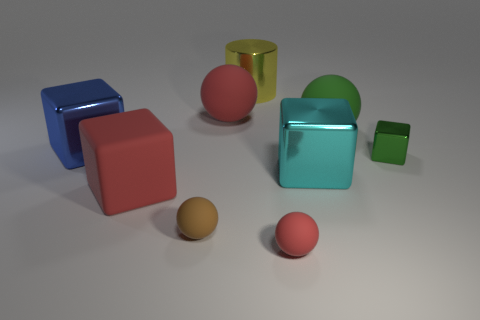What shape is the big shiny thing that is in front of the big red rubber ball and to the right of the red block?
Your answer should be very brief. Cube. Are there any tiny brown spheres?
Your answer should be very brief. Yes. There is a red thing that is the same shape as the cyan metal thing; what is it made of?
Offer a terse response. Rubber. There is a large rubber thing that is on the right side of the red sphere in front of the large cube that is right of the yellow metal cylinder; what is its shape?
Your answer should be very brief. Sphere. There is a big sphere that is the same color as the tiny metal object; what is it made of?
Keep it short and to the point. Rubber. What number of other big green matte objects have the same shape as the large green object?
Keep it short and to the point. 0. Do the big rubber thing in front of the green sphere and the tiny rubber object that is to the right of the yellow cylinder have the same color?
Make the answer very short. Yes. There is a red block that is the same size as the shiny cylinder; what is its material?
Provide a succinct answer. Rubber. Are there any red metallic cylinders of the same size as the red block?
Offer a terse response. No. Are there fewer big blue shiny things that are behind the big yellow metal object than red balls?
Give a very brief answer. Yes. 